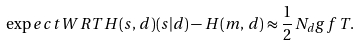Convert formula to latex. <formula><loc_0><loc_0><loc_500><loc_500>\exp e c t W R T { H ( s , \, d ) } { ( s | d ) } - H ( m , \, d ) \approx \frac { 1 } { 2 } \, N _ { d } g f \, T .</formula> 